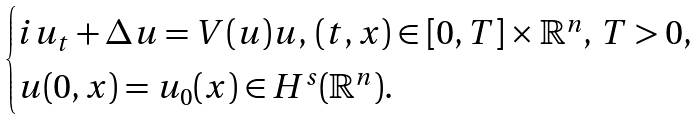<formula> <loc_0><loc_0><loc_500><loc_500>\begin{cases} i u _ { t } + \Delta u = V ( u ) u , \, ( t , x ) \in \mathbb { [ } 0 , T ] \times \mathbb { R } ^ { n } , \, T > 0 , \\ u ( 0 , x ) = u _ { 0 } ( x ) \in H ^ { s } ( \mathbb { R } ^ { n } ) . \end{cases}</formula> 